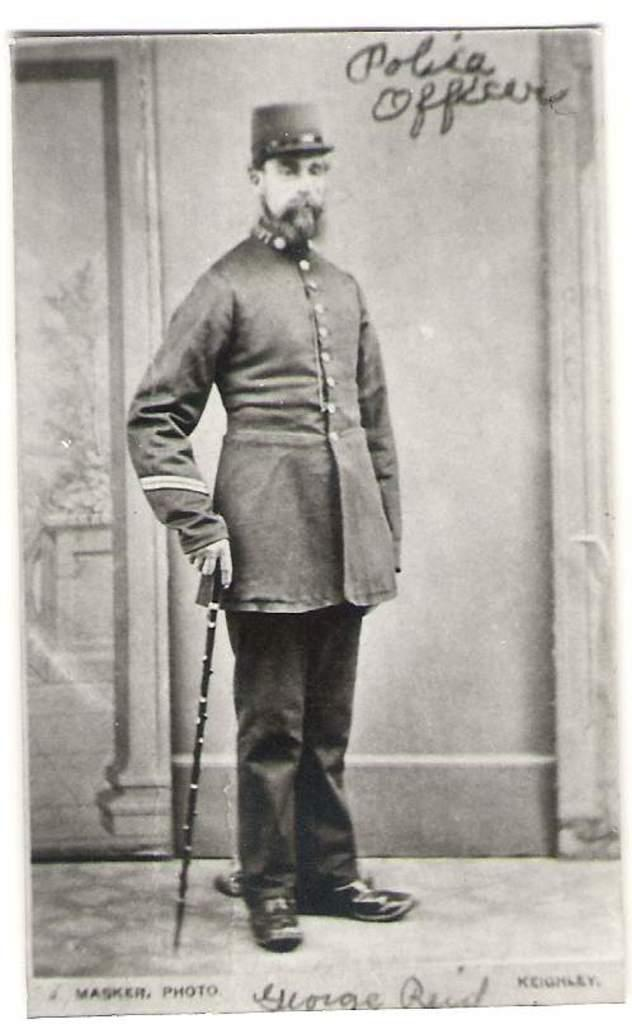<image>
Present a compact description of the photo's key features. a man is labeled police officer and stand with a stick in his hand 